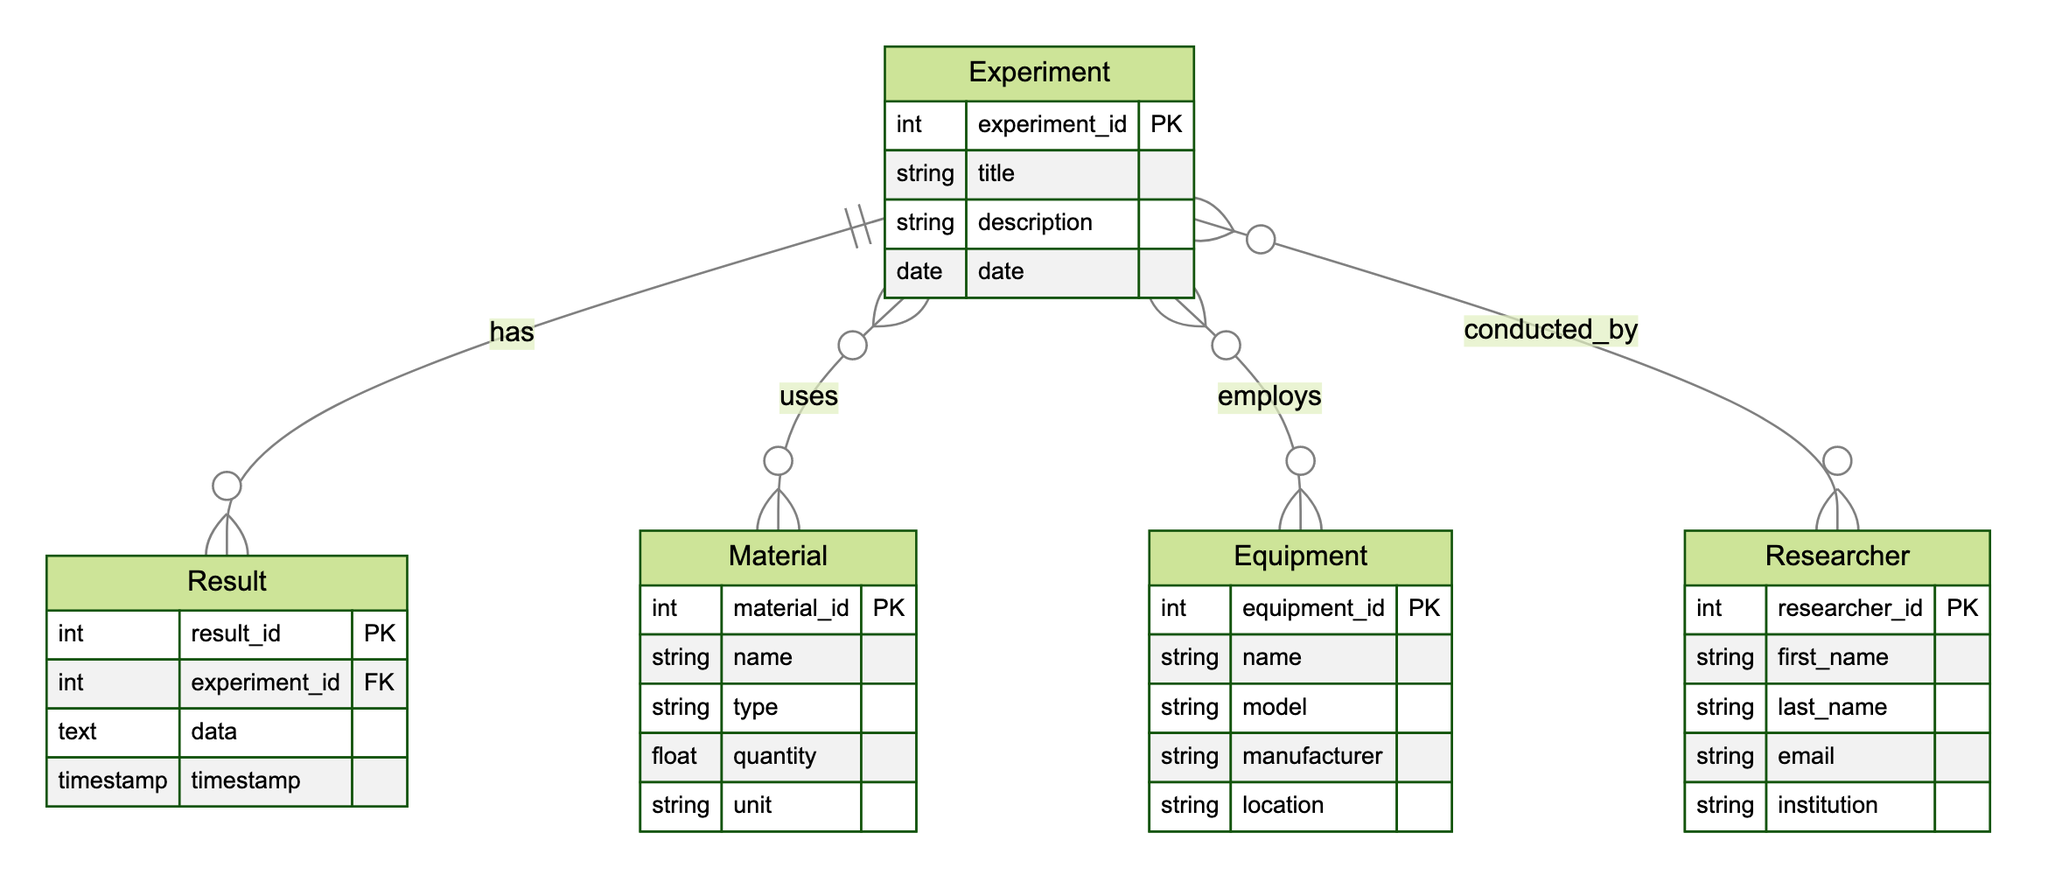What entities are involved in the experiment tracking system? The diagram includes five entities: Experiment, Material, Equipment, Researcher, and Result. Each entity is represented within the ERD, depicting the various components of the laboratory experiment tracking system.
Answer: Experiment, Material, Equipment, Researcher, Result How many attributes does the Equipment entity have? The Equipment entity contains five attributes: equipment_id, name, model, manufacturer, and location. This count is determined by examining the attributes listed under the Equipment entity in the diagram.
Answer: Five What relationship exists between the Experiment and Researcher entities? The relationship between Experiment and Researcher is defined as "conducted_by". This relationship is indicated by the line connecting the two entities in the diagram, specifying how they interact with each other.
Answer: conducted_by Which entity has a foreign key referencing Experiment? The Result entity contains a foreign key named experiment_id, which references the Experiment entity. This relationship is established through the connecting line and indicates the Result's dependence on the Experiment.
Answer: Result How many relationships involve the Experiment entity? The Experiment entity is involved in three relationships: it uses Material, employs Equipment, and is conducted by Researcher. By counting the distinct relationships linked to the Experiment entity in the diagram, the answer can be determined.
Answer: Three What type of relationship exists between Experiment and Material? The relationship type between Experiment and Material is defined as "many-to-many". This is specified in the diagram through the connection and the relationship label, indicating that multiple experiments can utilize multiple materials.
Answer: many-to-many What additional data does the Result entity store besides experiment_id? The Result entity stores two additional pieces of data: data (text) and timestamp. These attributes are illustrated in the entity's defined structure, indicating what information is captured in the results of an experiment.
Answer: data, timestamp What primary key does the Material entity have? The primary key for the Material entity is material_id, which is indicated in the diagram as a unique identifier for each material record. This allows for the identification of each material in the database.
Answer: material_id 